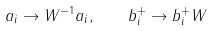Convert formula to latex. <formula><loc_0><loc_0><loc_500><loc_500>a _ { i } \to W ^ { - 1 } a _ { i } , \quad b _ { i } ^ { + } \to b _ { i } ^ { + } W</formula> 